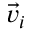Convert formula to latex. <formula><loc_0><loc_0><loc_500><loc_500>\vec { v } _ { i }</formula> 